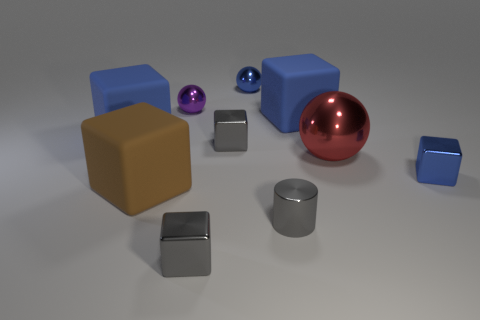There is a brown block that is the same size as the red sphere; what is its material?
Offer a very short reply. Rubber. How many cubes are left of the purple metal sphere and in front of the cylinder?
Give a very brief answer. 0. Do the tiny cylinder and the tiny gray cube that is behind the big brown block have the same material?
Your response must be concise. Yes. Are there an equal number of small gray metallic cylinders behind the purple thing and red objects?
Your response must be concise. No. What is the color of the small metal sphere that is behind the small purple ball?
Make the answer very short. Blue. How many other objects are the same color as the tiny metallic cylinder?
Ensure brevity in your answer.  2. Is there any other thing that has the same size as the red ball?
Your response must be concise. Yes. Do the sphere that is left of the blue metallic sphere and the cylinder have the same size?
Your answer should be compact. Yes. There is a small blue sphere that is behind the purple sphere; what is it made of?
Your answer should be compact. Metal. What number of rubber things are large purple balls or gray cylinders?
Your answer should be very brief. 0. 